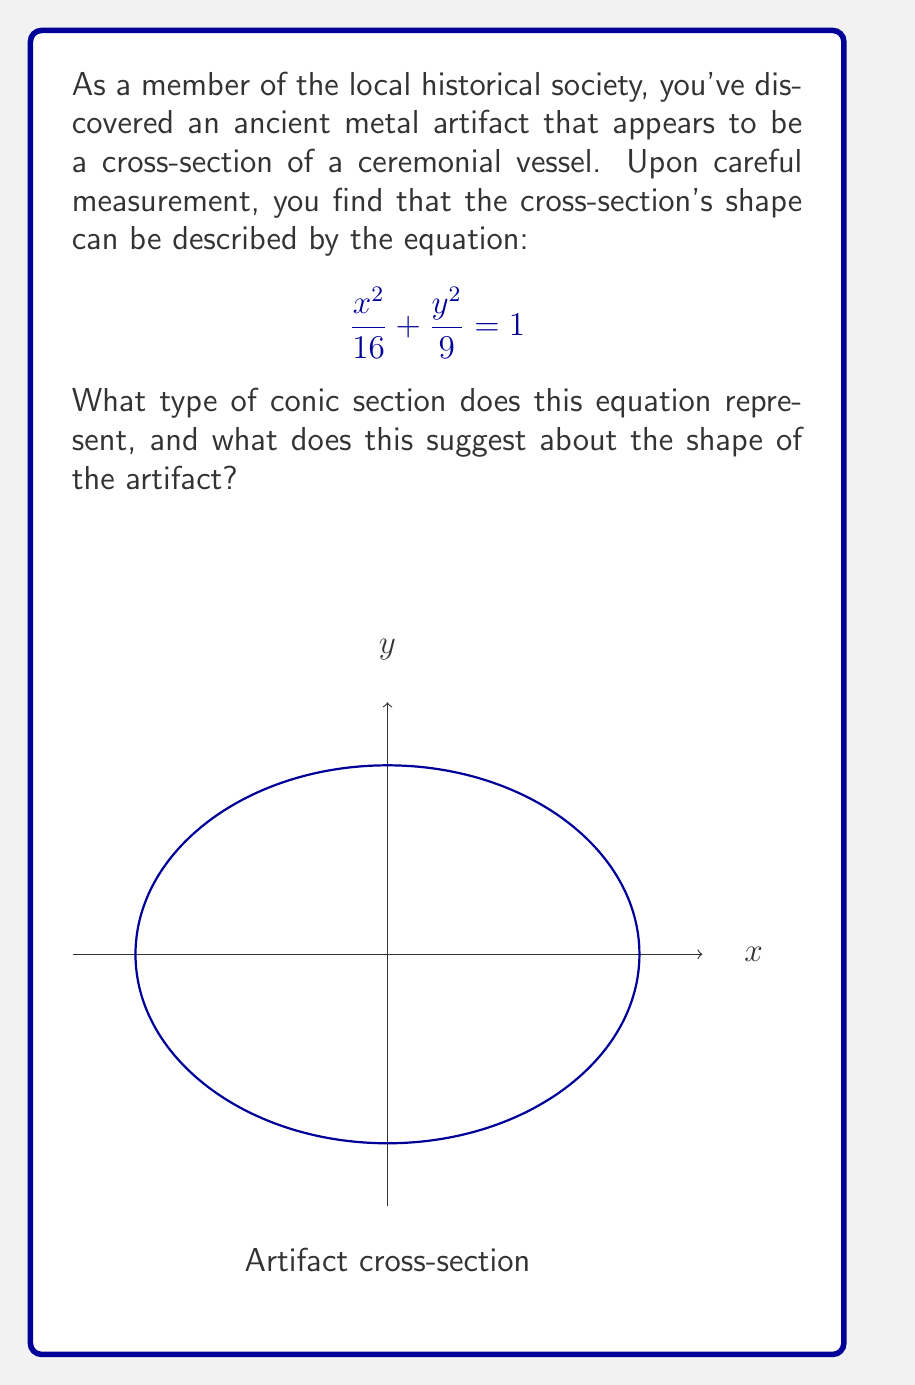Could you help me with this problem? To determine the shape of the artifact, we need to analyze the given equation:

$$\frac{x^2}{16} + \frac{y^2}{9} = 1$$

1) First, let's recognize the standard form of this equation:
   $$\frac{x^2}{a^2} + \frac{y^2}{b^2} = 1$$

   Where $a^2 = 16$ and $b^2 = 9$.

2) This is the standard form of an ellipse equation when both $a^2$ and $b^2$ are positive.

3) We can confirm this by calculating $a$ and $b$:
   $a = \sqrt{16} = 4$
   $b = \sqrt{9} = 3$

4) Since both $a$ and $b$ are real numbers, and $a \neq b$, this confirms that the equation represents an ellipse.

5) The ellipse is centered at the origin (0,0) because there are no terms adding to $x$ or $y$ inside the parentheses.

6) The semi-major axis is 4 units long (in the x-direction), and the semi-minor axis is 3 units long (in the y-direction).

Therefore, the cross-section of the artifact is an ellipse. This suggests that the artifact itself is likely an ellipsoid, which could be a flattened spherical shape or an elongated oval shape, depending on its third dimension.
Answer: Ellipse; artifact likely an ellipsoid 